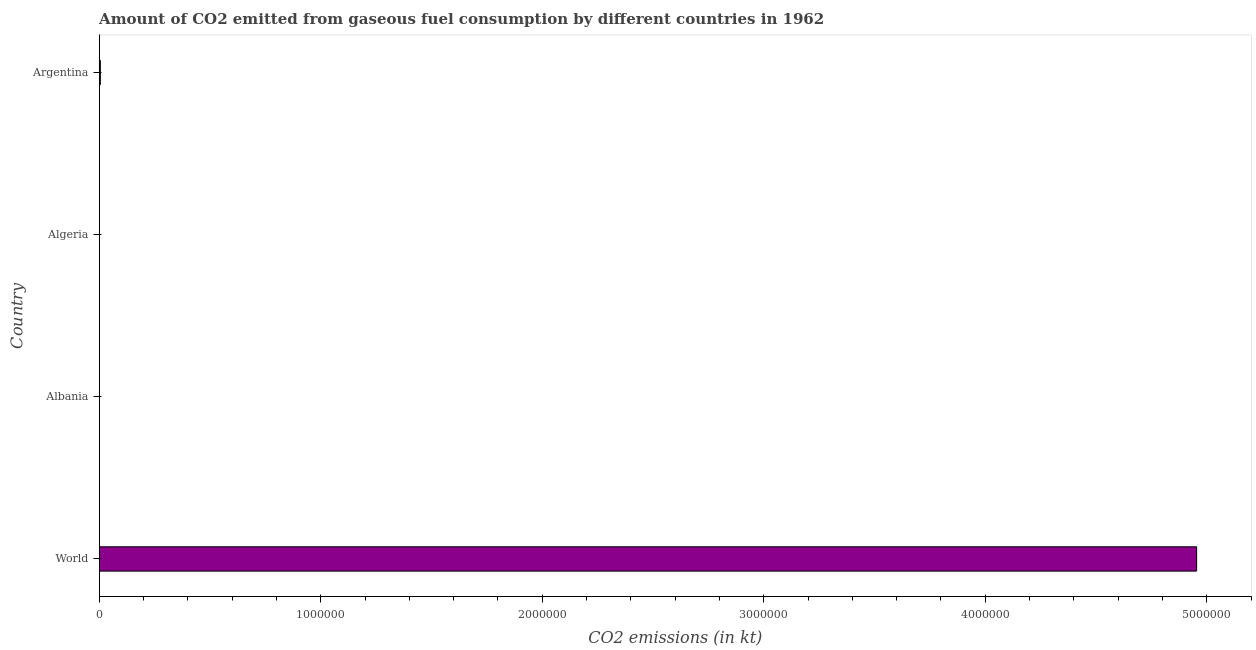Does the graph contain any zero values?
Provide a short and direct response. No. Does the graph contain grids?
Ensure brevity in your answer.  No. What is the title of the graph?
Your answer should be compact. Amount of CO2 emitted from gaseous fuel consumption by different countries in 1962. What is the label or title of the X-axis?
Give a very brief answer. CO2 emissions (in kt). What is the co2 emissions from gaseous fuel consumption in Algeria?
Offer a terse response. 689.4. Across all countries, what is the maximum co2 emissions from gaseous fuel consumption?
Keep it short and to the point. 4.95e+06. Across all countries, what is the minimum co2 emissions from gaseous fuel consumption?
Your response must be concise. 84.34. In which country was the co2 emissions from gaseous fuel consumption minimum?
Keep it short and to the point. Albania. What is the sum of the co2 emissions from gaseous fuel consumption?
Your response must be concise. 4.96e+06. What is the difference between the co2 emissions from gaseous fuel consumption in Algeria and Argentina?
Give a very brief answer. -4422.4. What is the average co2 emissions from gaseous fuel consumption per country?
Keep it short and to the point. 1.24e+06. What is the median co2 emissions from gaseous fuel consumption?
Make the answer very short. 2900.6. In how many countries, is the co2 emissions from gaseous fuel consumption greater than 2400000 kt?
Make the answer very short. 1. Is the co2 emissions from gaseous fuel consumption in Algeria less than that in World?
Offer a very short reply. Yes. Is the difference between the co2 emissions from gaseous fuel consumption in Albania and World greater than the difference between any two countries?
Make the answer very short. Yes. What is the difference between the highest and the second highest co2 emissions from gaseous fuel consumption?
Offer a terse response. 4.95e+06. What is the difference between the highest and the lowest co2 emissions from gaseous fuel consumption?
Your response must be concise. 4.95e+06. In how many countries, is the co2 emissions from gaseous fuel consumption greater than the average co2 emissions from gaseous fuel consumption taken over all countries?
Keep it short and to the point. 1. How many countries are there in the graph?
Make the answer very short. 4. What is the difference between two consecutive major ticks on the X-axis?
Give a very brief answer. 1.00e+06. What is the CO2 emissions (in kt) of World?
Your answer should be compact. 4.95e+06. What is the CO2 emissions (in kt) in Albania?
Your response must be concise. 84.34. What is the CO2 emissions (in kt) of Algeria?
Ensure brevity in your answer.  689.4. What is the CO2 emissions (in kt) in Argentina?
Provide a succinct answer. 5111.8. What is the difference between the CO2 emissions (in kt) in World and Albania?
Make the answer very short. 4.95e+06. What is the difference between the CO2 emissions (in kt) in World and Algeria?
Offer a terse response. 4.95e+06. What is the difference between the CO2 emissions (in kt) in World and Argentina?
Provide a short and direct response. 4.95e+06. What is the difference between the CO2 emissions (in kt) in Albania and Algeria?
Provide a short and direct response. -605.05. What is the difference between the CO2 emissions (in kt) in Albania and Argentina?
Your answer should be compact. -5027.46. What is the difference between the CO2 emissions (in kt) in Algeria and Argentina?
Offer a very short reply. -4422.4. What is the ratio of the CO2 emissions (in kt) in World to that in Albania?
Give a very brief answer. 5.87e+04. What is the ratio of the CO2 emissions (in kt) in World to that in Algeria?
Offer a very short reply. 7186.17. What is the ratio of the CO2 emissions (in kt) in World to that in Argentina?
Offer a very short reply. 969.15. What is the ratio of the CO2 emissions (in kt) in Albania to that in Algeria?
Make the answer very short. 0.12. What is the ratio of the CO2 emissions (in kt) in Albania to that in Argentina?
Offer a very short reply. 0.02. What is the ratio of the CO2 emissions (in kt) in Algeria to that in Argentina?
Ensure brevity in your answer.  0.14. 